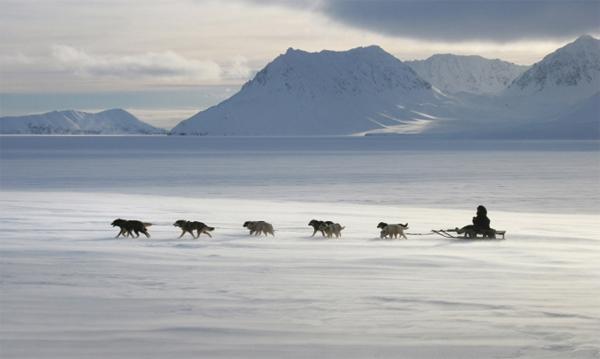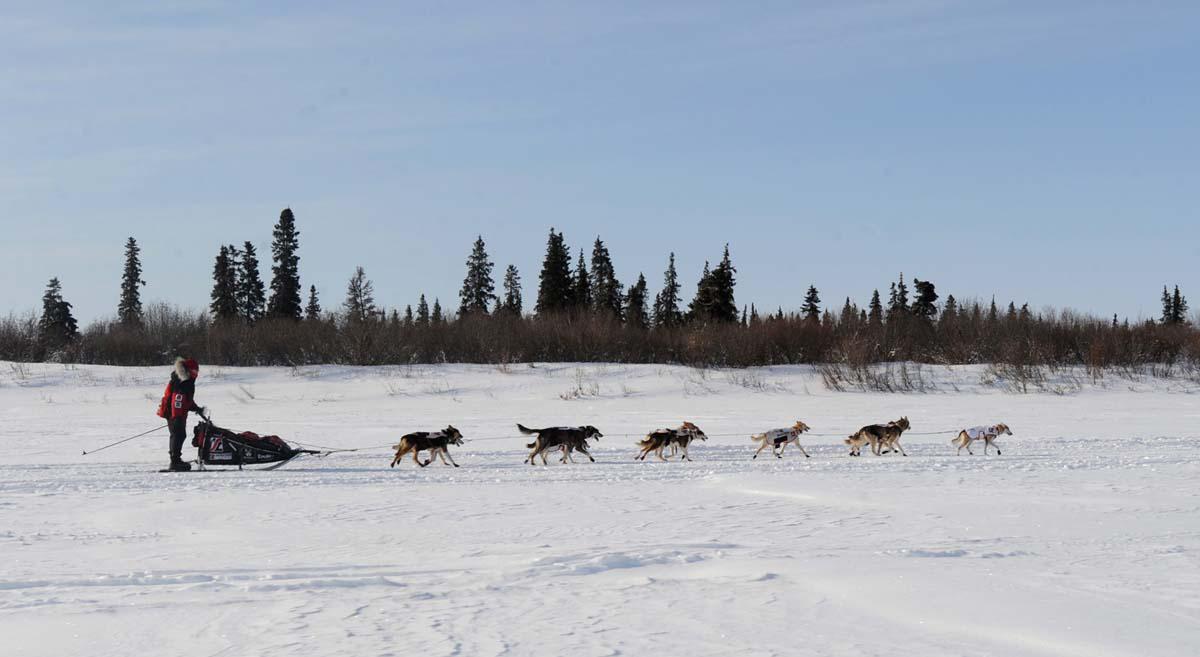The first image is the image on the left, the second image is the image on the right. Evaluate the accuracy of this statement regarding the images: "Less than three dogs are visible in one of the images.". Is it true? Answer yes or no. No. The first image is the image on the left, the second image is the image on the right. Considering the images on both sides, is "One image shows no more than two harnessed dogs, which are moving across the snow." valid? Answer yes or no. No. 